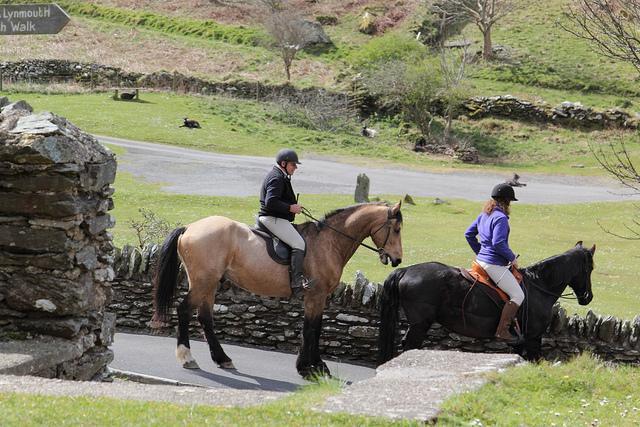How many horses are in the picture?
Give a very brief answer. 2. How many horses are there in the image?
Give a very brief answer. 2. How many people are there?
Give a very brief answer. 2. How many horses are there?
Give a very brief answer. 2. How many pizza slices have green vegetables on them?
Give a very brief answer. 0. 